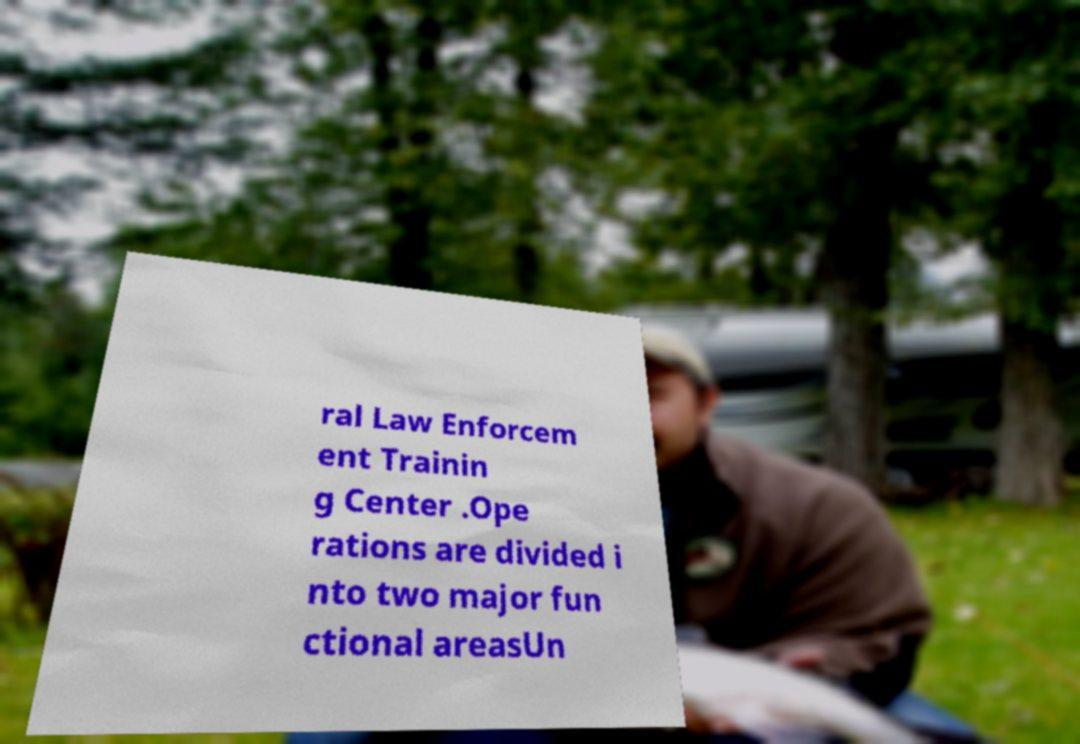Please identify and transcribe the text found in this image. ral Law Enforcem ent Trainin g Center .Ope rations are divided i nto two major fun ctional areasUn 